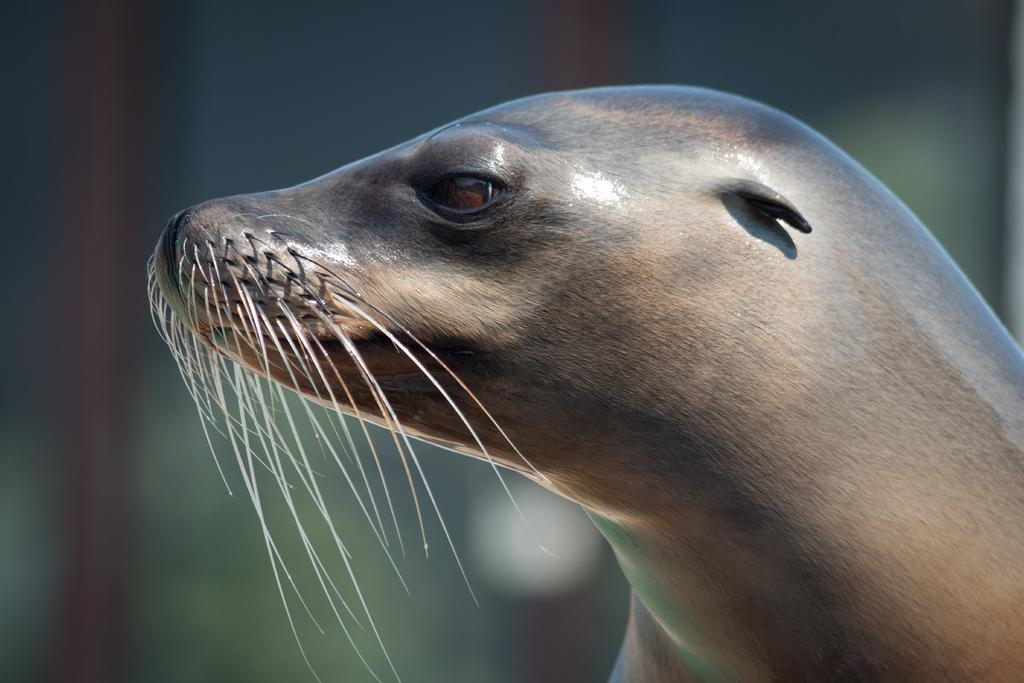What animal is the main subject of the image? There is a black seal in the image. Can you describe the background of the image? The background of the image is blurred. How many dogs are visible in the image? There are no dogs present in the image; it features a black seal. What type of mouth does the rainstorm have in the image? There is no rainstorm present in the image, so it does not have a mouth. 